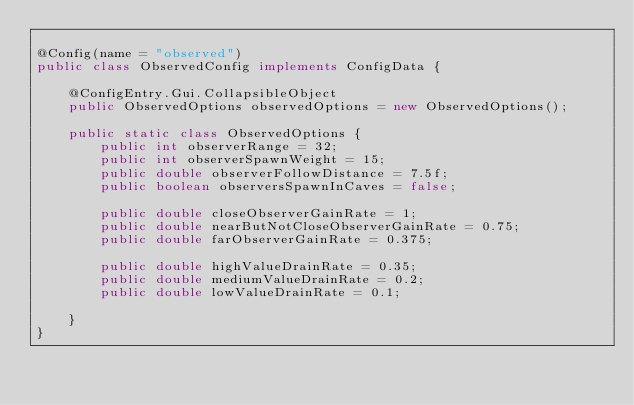Convert code to text. <code><loc_0><loc_0><loc_500><loc_500><_Java_>
@Config(name = "observed")
public class ObservedConfig implements ConfigData {

    @ConfigEntry.Gui.CollapsibleObject
    public ObservedOptions observedOptions = new ObservedOptions();

    public static class ObservedOptions {
        public int observerRange = 32;
        public int observerSpawnWeight = 15;
        public double observerFollowDistance = 7.5f;
        public boolean observersSpawnInCaves = false;

        public double closeObserverGainRate = 1;
        public double nearButNotCloseObserverGainRate = 0.75;
        public double farObserverGainRate = 0.375;

        public double highValueDrainRate = 0.35;
        public double mediumValueDrainRate = 0.2;
        public double lowValueDrainRate = 0.1;

    }
}
</code> 